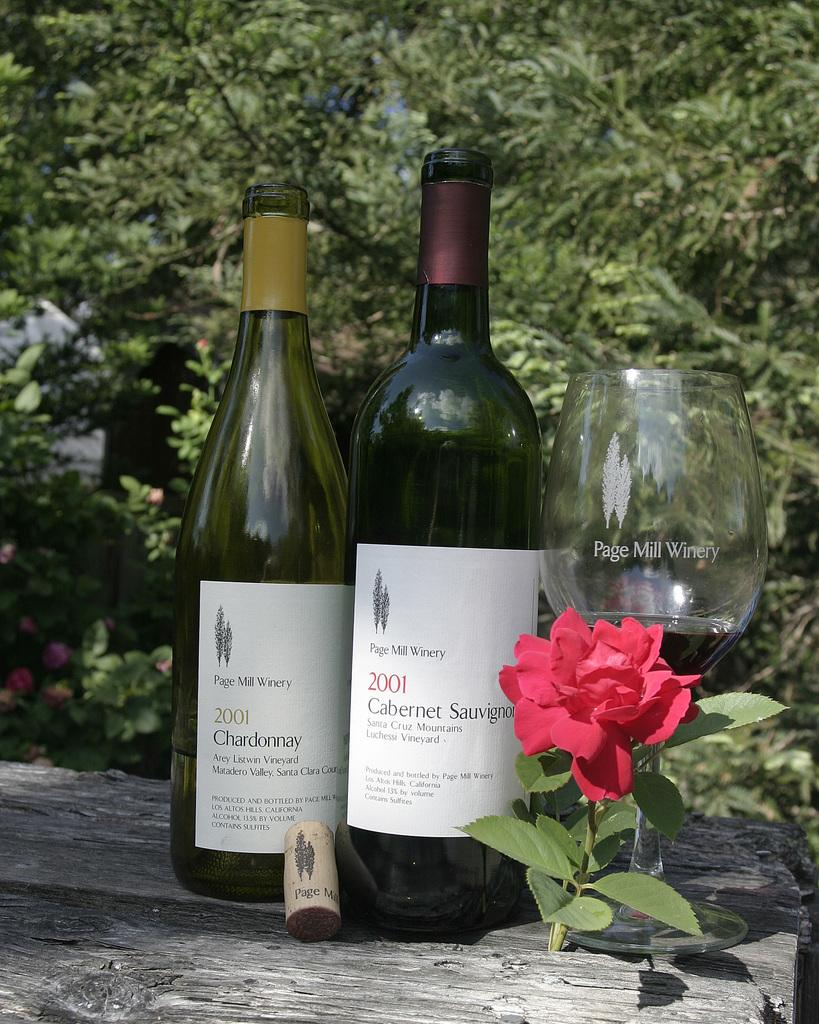<image>
Create a compact narrative representing the image presented. Two bottles of 2001 wines are set next to a Page Mill Winery glass. 